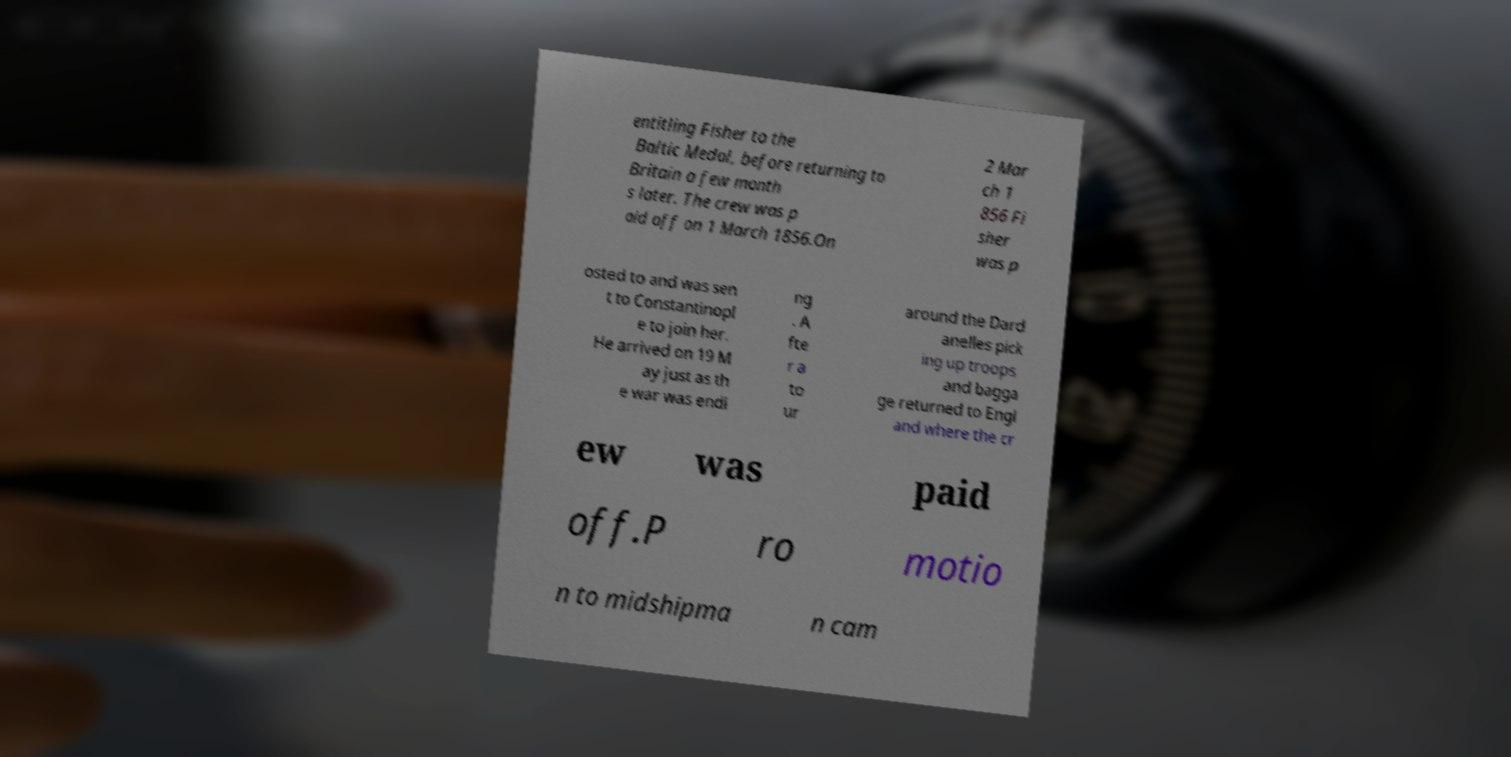I need the written content from this picture converted into text. Can you do that? entitling Fisher to the Baltic Medal, before returning to Britain a few month s later. The crew was p aid off on 1 March 1856.On 2 Mar ch 1 856 Fi sher was p osted to and was sen t to Constantinopl e to join her. He arrived on 19 M ay just as th e war was endi ng . A fte r a to ur around the Dard anelles pick ing up troops and bagga ge returned to Engl and where the cr ew was paid off.P ro motio n to midshipma n cam 